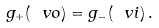<formula> <loc_0><loc_0><loc_500><loc_500>g _ { + } ( \ v o ) = g _ { - } ( \ v i ) \, .</formula> 